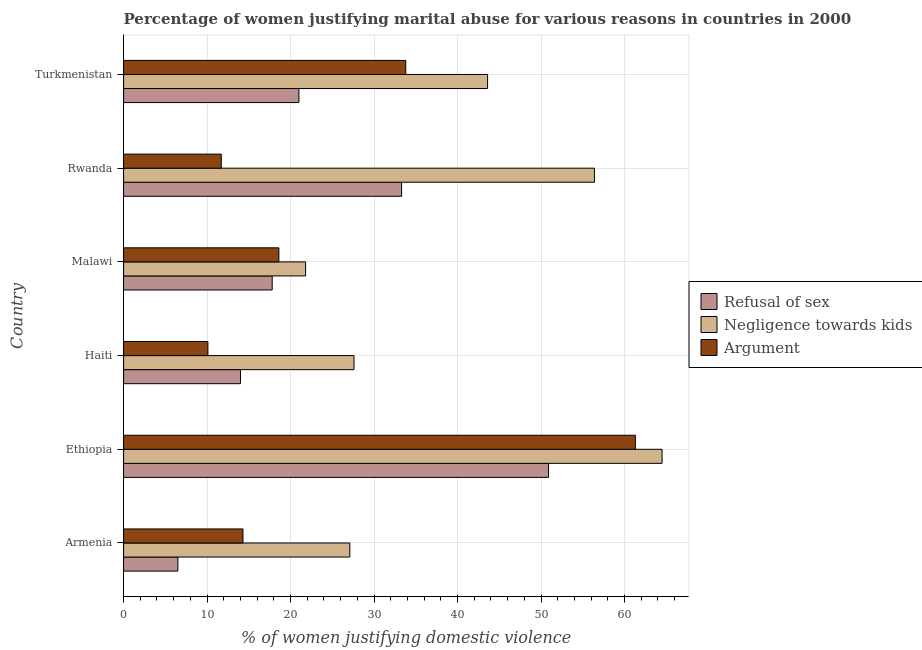Are the number of bars on each tick of the Y-axis equal?
Provide a short and direct response. Yes. What is the label of the 5th group of bars from the top?
Your answer should be very brief. Ethiopia. Across all countries, what is the maximum percentage of women justifying domestic violence due to negligence towards kids?
Your response must be concise. 64.5. In which country was the percentage of women justifying domestic violence due to arguments maximum?
Offer a terse response. Ethiopia. In which country was the percentage of women justifying domestic violence due to refusal of sex minimum?
Provide a succinct answer. Armenia. What is the total percentage of women justifying domestic violence due to arguments in the graph?
Your answer should be compact. 149.8. What is the difference between the percentage of women justifying domestic violence due to arguments in Haiti and that in Malawi?
Offer a terse response. -8.5. What is the average percentage of women justifying domestic violence due to negligence towards kids per country?
Your response must be concise. 40.17. What is the difference between the percentage of women justifying domestic violence due to refusal of sex and percentage of women justifying domestic violence due to arguments in Malawi?
Offer a terse response. -0.8. What is the ratio of the percentage of women justifying domestic violence due to negligence towards kids in Armenia to that in Malawi?
Your answer should be very brief. 1.24. What is the difference between the highest and the second highest percentage of women justifying domestic violence due to negligence towards kids?
Ensure brevity in your answer.  8.1. What is the difference between the highest and the lowest percentage of women justifying domestic violence due to arguments?
Give a very brief answer. 51.2. Is the sum of the percentage of women justifying domestic violence due to refusal of sex in Armenia and Turkmenistan greater than the maximum percentage of women justifying domestic violence due to negligence towards kids across all countries?
Your answer should be compact. No. What does the 1st bar from the top in Armenia represents?
Provide a short and direct response. Argument. What does the 1st bar from the bottom in Ethiopia represents?
Provide a short and direct response. Refusal of sex. How many bars are there?
Your answer should be compact. 18. Does the graph contain grids?
Ensure brevity in your answer.  Yes. Where does the legend appear in the graph?
Give a very brief answer. Center right. How many legend labels are there?
Offer a terse response. 3. How are the legend labels stacked?
Offer a terse response. Vertical. What is the title of the graph?
Make the answer very short. Percentage of women justifying marital abuse for various reasons in countries in 2000. What is the label or title of the X-axis?
Provide a short and direct response. % of women justifying domestic violence. What is the label or title of the Y-axis?
Provide a short and direct response. Country. What is the % of women justifying domestic violence of Refusal of sex in Armenia?
Your answer should be very brief. 6.5. What is the % of women justifying domestic violence of Negligence towards kids in Armenia?
Offer a very short reply. 27.1. What is the % of women justifying domestic violence of Refusal of sex in Ethiopia?
Your response must be concise. 50.9. What is the % of women justifying domestic violence of Negligence towards kids in Ethiopia?
Keep it short and to the point. 64.5. What is the % of women justifying domestic violence of Argument in Ethiopia?
Offer a very short reply. 61.3. What is the % of women justifying domestic violence of Negligence towards kids in Haiti?
Ensure brevity in your answer.  27.6. What is the % of women justifying domestic violence of Argument in Haiti?
Give a very brief answer. 10.1. What is the % of women justifying domestic violence in Negligence towards kids in Malawi?
Make the answer very short. 21.8. What is the % of women justifying domestic violence of Refusal of sex in Rwanda?
Offer a terse response. 33.3. What is the % of women justifying domestic violence in Negligence towards kids in Rwanda?
Your answer should be very brief. 56.4. What is the % of women justifying domestic violence in Argument in Rwanda?
Provide a succinct answer. 11.7. What is the % of women justifying domestic violence in Refusal of sex in Turkmenistan?
Provide a short and direct response. 21. What is the % of women justifying domestic violence of Negligence towards kids in Turkmenistan?
Make the answer very short. 43.6. What is the % of women justifying domestic violence of Argument in Turkmenistan?
Ensure brevity in your answer.  33.8. Across all countries, what is the maximum % of women justifying domestic violence in Refusal of sex?
Give a very brief answer. 50.9. Across all countries, what is the maximum % of women justifying domestic violence in Negligence towards kids?
Make the answer very short. 64.5. Across all countries, what is the maximum % of women justifying domestic violence of Argument?
Provide a succinct answer. 61.3. Across all countries, what is the minimum % of women justifying domestic violence of Negligence towards kids?
Your response must be concise. 21.8. What is the total % of women justifying domestic violence in Refusal of sex in the graph?
Ensure brevity in your answer.  143.5. What is the total % of women justifying domestic violence in Negligence towards kids in the graph?
Offer a terse response. 241. What is the total % of women justifying domestic violence of Argument in the graph?
Provide a succinct answer. 149.8. What is the difference between the % of women justifying domestic violence of Refusal of sex in Armenia and that in Ethiopia?
Keep it short and to the point. -44.4. What is the difference between the % of women justifying domestic violence in Negligence towards kids in Armenia and that in Ethiopia?
Ensure brevity in your answer.  -37.4. What is the difference between the % of women justifying domestic violence in Argument in Armenia and that in Ethiopia?
Your answer should be very brief. -47. What is the difference between the % of women justifying domestic violence of Refusal of sex in Armenia and that in Haiti?
Your response must be concise. -7.5. What is the difference between the % of women justifying domestic violence in Argument in Armenia and that in Haiti?
Keep it short and to the point. 4.2. What is the difference between the % of women justifying domestic violence of Negligence towards kids in Armenia and that in Malawi?
Your answer should be very brief. 5.3. What is the difference between the % of women justifying domestic violence of Refusal of sex in Armenia and that in Rwanda?
Offer a terse response. -26.8. What is the difference between the % of women justifying domestic violence in Negligence towards kids in Armenia and that in Rwanda?
Keep it short and to the point. -29.3. What is the difference between the % of women justifying domestic violence of Negligence towards kids in Armenia and that in Turkmenistan?
Make the answer very short. -16.5. What is the difference between the % of women justifying domestic violence of Argument in Armenia and that in Turkmenistan?
Offer a terse response. -19.5. What is the difference between the % of women justifying domestic violence in Refusal of sex in Ethiopia and that in Haiti?
Your response must be concise. 36.9. What is the difference between the % of women justifying domestic violence in Negligence towards kids in Ethiopia and that in Haiti?
Your answer should be compact. 36.9. What is the difference between the % of women justifying domestic violence of Argument in Ethiopia and that in Haiti?
Make the answer very short. 51.2. What is the difference between the % of women justifying domestic violence of Refusal of sex in Ethiopia and that in Malawi?
Your answer should be very brief. 33.1. What is the difference between the % of women justifying domestic violence of Negligence towards kids in Ethiopia and that in Malawi?
Make the answer very short. 42.7. What is the difference between the % of women justifying domestic violence of Argument in Ethiopia and that in Malawi?
Keep it short and to the point. 42.7. What is the difference between the % of women justifying domestic violence of Refusal of sex in Ethiopia and that in Rwanda?
Ensure brevity in your answer.  17.6. What is the difference between the % of women justifying domestic violence of Negligence towards kids in Ethiopia and that in Rwanda?
Your answer should be compact. 8.1. What is the difference between the % of women justifying domestic violence in Argument in Ethiopia and that in Rwanda?
Provide a succinct answer. 49.6. What is the difference between the % of women justifying domestic violence of Refusal of sex in Ethiopia and that in Turkmenistan?
Ensure brevity in your answer.  29.9. What is the difference between the % of women justifying domestic violence of Negligence towards kids in Ethiopia and that in Turkmenistan?
Your response must be concise. 20.9. What is the difference between the % of women justifying domestic violence of Argument in Ethiopia and that in Turkmenistan?
Ensure brevity in your answer.  27.5. What is the difference between the % of women justifying domestic violence in Refusal of sex in Haiti and that in Malawi?
Give a very brief answer. -3.8. What is the difference between the % of women justifying domestic violence in Negligence towards kids in Haiti and that in Malawi?
Offer a terse response. 5.8. What is the difference between the % of women justifying domestic violence in Argument in Haiti and that in Malawi?
Offer a very short reply. -8.5. What is the difference between the % of women justifying domestic violence of Refusal of sex in Haiti and that in Rwanda?
Offer a very short reply. -19.3. What is the difference between the % of women justifying domestic violence in Negligence towards kids in Haiti and that in Rwanda?
Your answer should be compact. -28.8. What is the difference between the % of women justifying domestic violence of Refusal of sex in Haiti and that in Turkmenistan?
Your answer should be compact. -7. What is the difference between the % of women justifying domestic violence in Negligence towards kids in Haiti and that in Turkmenistan?
Keep it short and to the point. -16. What is the difference between the % of women justifying domestic violence in Argument in Haiti and that in Turkmenistan?
Provide a short and direct response. -23.7. What is the difference between the % of women justifying domestic violence in Refusal of sex in Malawi and that in Rwanda?
Offer a terse response. -15.5. What is the difference between the % of women justifying domestic violence of Negligence towards kids in Malawi and that in Rwanda?
Your response must be concise. -34.6. What is the difference between the % of women justifying domestic violence of Argument in Malawi and that in Rwanda?
Give a very brief answer. 6.9. What is the difference between the % of women justifying domestic violence in Negligence towards kids in Malawi and that in Turkmenistan?
Offer a terse response. -21.8. What is the difference between the % of women justifying domestic violence in Argument in Malawi and that in Turkmenistan?
Make the answer very short. -15.2. What is the difference between the % of women justifying domestic violence of Refusal of sex in Rwanda and that in Turkmenistan?
Ensure brevity in your answer.  12.3. What is the difference between the % of women justifying domestic violence of Negligence towards kids in Rwanda and that in Turkmenistan?
Your response must be concise. 12.8. What is the difference between the % of women justifying domestic violence in Argument in Rwanda and that in Turkmenistan?
Keep it short and to the point. -22.1. What is the difference between the % of women justifying domestic violence of Refusal of sex in Armenia and the % of women justifying domestic violence of Negligence towards kids in Ethiopia?
Keep it short and to the point. -58. What is the difference between the % of women justifying domestic violence in Refusal of sex in Armenia and the % of women justifying domestic violence in Argument in Ethiopia?
Your answer should be very brief. -54.8. What is the difference between the % of women justifying domestic violence in Negligence towards kids in Armenia and the % of women justifying domestic violence in Argument in Ethiopia?
Give a very brief answer. -34.2. What is the difference between the % of women justifying domestic violence of Refusal of sex in Armenia and the % of women justifying domestic violence of Negligence towards kids in Haiti?
Provide a short and direct response. -21.1. What is the difference between the % of women justifying domestic violence in Refusal of sex in Armenia and the % of women justifying domestic violence in Negligence towards kids in Malawi?
Your response must be concise. -15.3. What is the difference between the % of women justifying domestic violence in Negligence towards kids in Armenia and the % of women justifying domestic violence in Argument in Malawi?
Make the answer very short. 8.5. What is the difference between the % of women justifying domestic violence of Refusal of sex in Armenia and the % of women justifying domestic violence of Negligence towards kids in Rwanda?
Provide a short and direct response. -49.9. What is the difference between the % of women justifying domestic violence in Refusal of sex in Armenia and the % of women justifying domestic violence in Negligence towards kids in Turkmenistan?
Make the answer very short. -37.1. What is the difference between the % of women justifying domestic violence in Refusal of sex in Armenia and the % of women justifying domestic violence in Argument in Turkmenistan?
Keep it short and to the point. -27.3. What is the difference between the % of women justifying domestic violence in Negligence towards kids in Armenia and the % of women justifying domestic violence in Argument in Turkmenistan?
Your response must be concise. -6.7. What is the difference between the % of women justifying domestic violence in Refusal of sex in Ethiopia and the % of women justifying domestic violence in Negligence towards kids in Haiti?
Ensure brevity in your answer.  23.3. What is the difference between the % of women justifying domestic violence of Refusal of sex in Ethiopia and the % of women justifying domestic violence of Argument in Haiti?
Make the answer very short. 40.8. What is the difference between the % of women justifying domestic violence in Negligence towards kids in Ethiopia and the % of women justifying domestic violence in Argument in Haiti?
Offer a terse response. 54.4. What is the difference between the % of women justifying domestic violence in Refusal of sex in Ethiopia and the % of women justifying domestic violence in Negligence towards kids in Malawi?
Your response must be concise. 29.1. What is the difference between the % of women justifying domestic violence in Refusal of sex in Ethiopia and the % of women justifying domestic violence in Argument in Malawi?
Your answer should be compact. 32.3. What is the difference between the % of women justifying domestic violence in Negligence towards kids in Ethiopia and the % of women justifying domestic violence in Argument in Malawi?
Provide a short and direct response. 45.9. What is the difference between the % of women justifying domestic violence in Refusal of sex in Ethiopia and the % of women justifying domestic violence in Negligence towards kids in Rwanda?
Your answer should be very brief. -5.5. What is the difference between the % of women justifying domestic violence in Refusal of sex in Ethiopia and the % of women justifying domestic violence in Argument in Rwanda?
Provide a succinct answer. 39.2. What is the difference between the % of women justifying domestic violence of Negligence towards kids in Ethiopia and the % of women justifying domestic violence of Argument in Rwanda?
Make the answer very short. 52.8. What is the difference between the % of women justifying domestic violence in Refusal of sex in Ethiopia and the % of women justifying domestic violence in Negligence towards kids in Turkmenistan?
Give a very brief answer. 7.3. What is the difference between the % of women justifying domestic violence in Refusal of sex in Ethiopia and the % of women justifying domestic violence in Argument in Turkmenistan?
Your answer should be very brief. 17.1. What is the difference between the % of women justifying domestic violence of Negligence towards kids in Ethiopia and the % of women justifying domestic violence of Argument in Turkmenistan?
Offer a terse response. 30.7. What is the difference between the % of women justifying domestic violence of Refusal of sex in Haiti and the % of women justifying domestic violence of Argument in Malawi?
Offer a very short reply. -4.6. What is the difference between the % of women justifying domestic violence in Negligence towards kids in Haiti and the % of women justifying domestic violence in Argument in Malawi?
Your answer should be compact. 9. What is the difference between the % of women justifying domestic violence of Refusal of sex in Haiti and the % of women justifying domestic violence of Negligence towards kids in Rwanda?
Provide a succinct answer. -42.4. What is the difference between the % of women justifying domestic violence in Negligence towards kids in Haiti and the % of women justifying domestic violence in Argument in Rwanda?
Provide a short and direct response. 15.9. What is the difference between the % of women justifying domestic violence of Refusal of sex in Haiti and the % of women justifying domestic violence of Negligence towards kids in Turkmenistan?
Offer a terse response. -29.6. What is the difference between the % of women justifying domestic violence in Refusal of sex in Haiti and the % of women justifying domestic violence in Argument in Turkmenistan?
Your answer should be very brief. -19.8. What is the difference between the % of women justifying domestic violence in Refusal of sex in Malawi and the % of women justifying domestic violence in Negligence towards kids in Rwanda?
Offer a very short reply. -38.6. What is the difference between the % of women justifying domestic violence in Negligence towards kids in Malawi and the % of women justifying domestic violence in Argument in Rwanda?
Your answer should be very brief. 10.1. What is the difference between the % of women justifying domestic violence in Refusal of sex in Malawi and the % of women justifying domestic violence in Negligence towards kids in Turkmenistan?
Give a very brief answer. -25.8. What is the difference between the % of women justifying domestic violence in Refusal of sex in Rwanda and the % of women justifying domestic violence in Negligence towards kids in Turkmenistan?
Offer a terse response. -10.3. What is the difference between the % of women justifying domestic violence in Negligence towards kids in Rwanda and the % of women justifying domestic violence in Argument in Turkmenistan?
Offer a terse response. 22.6. What is the average % of women justifying domestic violence in Refusal of sex per country?
Your answer should be very brief. 23.92. What is the average % of women justifying domestic violence of Negligence towards kids per country?
Keep it short and to the point. 40.17. What is the average % of women justifying domestic violence of Argument per country?
Give a very brief answer. 24.97. What is the difference between the % of women justifying domestic violence in Refusal of sex and % of women justifying domestic violence in Negligence towards kids in Armenia?
Your answer should be compact. -20.6. What is the difference between the % of women justifying domestic violence in Refusal of sex and % of women justifying domestic violence in Negligence towards kids in Haiti?
Your response must be concise. -13.6. What is the difference between the % of women justifying domestic violence in Negligence towards kids and % of women justifying domestic violence in Argument in Haiti?
Make the answer very short. 17.5. What is the difference between the % of women justifying domestic violence of Negligence towards kids and % of women justifying domestic violence of Argument in Malawi?
Make the answer very short. 3.2. What is the difference between the % of women justifying domestic violence in Refusal of sex and % of women justifying domestic violence in Negligence towards kids in Rwanda?
Keep it short and to the point. -23.1. What is the difference between the % of women justifying domestic violence in Refusal of sex and % of women justifying domestic violence in Argument in Rwanda?
Offer a terse response. 21.6. What is the difference between the % of women justifying domestic violence of Negligence towards kids and % of women justifying domestic violence of Argument in Rwanda?
Give a very brief answer. 44.7. What is the difference between the % of women justifying domestic violence in Refusal of sex and % of women justifying domestic violence in Negligence towards kids in Turkmenistan?
Give a very brief answer. -22.6. What is the difference between the % of women justifying domestic violence in Negligence towards kids and % of women justifying domestic violence in Argument in Turkmenistan?
Give a very brief answer. 9.8. What is the ratio of the % of women justifying domestic violence in Refusal of sex in Armenia to that in Ethiopia?
Provide a short and direct response. 0.13. What is the ratio of the % of women justifying domestic violence of Negligence towards kids in Armenia to that in Ethiopia?
Give a very brief answer. 0.42. What is the ratio of the % of women justifying domestic violence in Argument in Armenia to that in Ethiopia?
Offer a terse response. 0.23. What is the ratio of the % of women justifying domestic violence of Refusal of sex in Armenia to that in Haiti?
Give a very brief answer. 0.46. What is the ratio of the % of women justifying domestic violence in Negligence towards kids in Armenia to that in Haiti?
Offer a terse response. 0.98. What is the ratio of the % of women justifying domestic violence of Argument in Armenia to that in Haiti?
Your answer should be very brief. 1.42. What is the ratio of the % of women justifying domestic violence of Refusal of sex in Armenia to that in Malawi?
Offer a very short reply. 0.37. What is the ratio of the % of women justifying domestic violence of Negligence towards kids in Armenia to that in Malawi?
Your answer should be compact. 1.24. What is the ratio of the % of women justifying domestic violence in Argument in Armenia to that in Malawi?
Provide a short and direct response. 0.77. What is the ratio of the % of women justifying domestic violence in Refusal of sex in Armenia to that in Rwanda?
Your response must be concise. 0.2. What is the ratio of the % of women justifying domestic violence of Negligence towards kids in Armenia to that in Rwanda?
Make the answer very short. 0.48. What is the ratio of the % of women justifying domestic violence in Argument in Armenia to that in Rwanda?
Give a very brief answer. 1.22. What is the ratio of the % of women justifying domestic violence in Refusal of sex in Armenia to that in Turkmenistan?
Your response must be concise. 0.31. What is the ratio of the % of women justifying domestic violence of Negligence towards kids in Armenia to that in Turkmenistan?
Give a very brief answer. 0.62. What is the ratio of the % of women justifying domestic violence in Argument in Armenia to that in Turkmenistan?
Give a very brief answer. 0.42. What is the ratio of the % of women justifying domestic violence in Refusal of sex in Ethiopia to that in Haiti?
Provide a short and direct response. 3.64. What is the ratio of the % of women justifying domestic violence of Negligence towards kids in Ethiopia to that in Haiti?
Give a very brief answer. 2.34. What is the ratio of the % of women justifying domestic violence in Argument in Ethiopia to that in Haiti?
Keep it short and to the point. 6.07. What is the ratio of the % of women justifying domestic violence in Refusal of sex in Ethiopia to that in Malawi?
Offer a very short reply. 2.86. What is the ratio of the % of women justifying domestic violence of Negligence towards kids in Ethiopia to that in Malawi?
Your answer should be compact. 2.96. What is the ratio of the % of women justifying domestic violence of Argument in Ethiopia to that in Malawi?
Provide a succinct answer. 3.3. What is the ratio of the % of women justifying domestic violence in Refusal of sex in Ethiopia to that in Rwanda?
Provide a succinct answer. 1.53. What is the ratio of the % of women justifying domestic violence in Negligence towards kids in Ethiopia to that in Rwanda?
Provide a succinct answer. 1.14. What is the ratio of the % of women justifying domestic violence in Argument in Ethiopia to that in Rwanda?
Your answer should be very brief. 5.24. What is the ratio of the % of women justifying domestic violence of Refusal of sex in Ethiopia to that in Turkmenistan?
Offer a very short reply. 2.42. What is the ratio of the % of women justifying domestic violence of Negligence towards kids in Ethiopia to that in Turkmenistan?
Give a very brief answer. 1.48. What is the ratio of the % of women justifying domestic violence of Argument in Ethiopia to that in Turkmenistan?
Your response must be concise. 1.81. What is the ratio of the % of women justifying domestic violence of Refusal of sex in Haiti to that in Malawi?
Offer a very short reply. 0.79. What is the ratio of the % of women justifying domestic violence of Negligence towards kids in Haiti to that in Malawi?
Your response must be concise. 1.27. What is the ratio of the % of women justifying domestic violence of Argument in Haiti to that in Malawi?
Provide a succinct answer. 0.54. What is the ratio of the % of women justifying domestic violence in Refusal of sex in Haiti to that in Rwanda?
Offer a very short reply. 0.42. What is the ratio of the % of women justifying domestic violence in Negligence towards kids in Haiti to that in Rwanda?
Your answer should be compact. 0.49. What is the ratio of the % of women justifying domestic violence of Argument in Haiti to that in Rwanda?
Provide a short and direct response. 0.86. What is the ratio of the % of women justifying domestic violence of Refusal of sex in Haiti to that in Turkmenistan?
Make the answer very short. 0.67. What is the ratio of the % of women justifying domestic violence in Negligence towards kids in Haiti to that in Turkmenistan?
Your answer should be compact. 0.63. What is the ratio of the % of women justifying domestic violence in Argument in Haiti to that in Turkmenistan?
Give a very brief answer. 0.3. What is the ratio of the % of women justifying domestic violence of Refusal of sex in Malawi to that in Rwanda?
Provide a succinct answer. 0.53. What is the ratio of the % of women justifying domestic violence of Negligence towards kids in Malawi to that in Rwanda?
Your response must be concise. 0.39. What is the ratio of the % of women justifying domestic violence in Argument in Malawi to that in Rwanda?
Give a very brief answer. 1.59. What is the ratio of the % of women justifying domestic violence of Refusal of sex in Malawi to that in Turkmenistan?
Ensure brevity in your answer.  0.85. What is the ratio of the % of women justifying domestic violence in Argument in Malawi to that in Turkmenistan?
Your answer should be compact. 0.55. What is the ratio of the % of women justifying domestic violence of Refusal of sex in Rwanda to that in Turkmenistan?
Your answer should be compact. 1.59. What is the ratio of the % of women justifying domestic violence of Negligence towards kids in Rwanda to that in Turkmenistan?
Ensure brevity in your answer.  1.29. What is the ratio of the % of women justifying domestic violence in Argument in Rwanda to that in Turkmenistan?
Provide a short and direct response. 0.35. What is the difference between the highest and the second highest % of women justifying domestic violence of Refusal of sex?
Make the answer very short. 17.6. What is the difference between the highest and the second highest % of women justifying domestic violence in Negligence towards kids?
Offer a terse response. 8.1. What is the difference between the highest and the second highest % of women justifying domestic violence of Argument?
Give a very brief answer. 27.5. What is the difference between the highest and the lowest % of women justifying domestic violence of Refusal of sex?
Your response must be concise. 44.4. What is the difference between the highest and the lowest % of women justifying domestic violence of Negligence towards kids?
Ensure brevity in your answer.  42.7. What is the difference between the highest and the lowest % of women justifying domestic violence of Argument?
Provide a short and direct response. 51.2. 